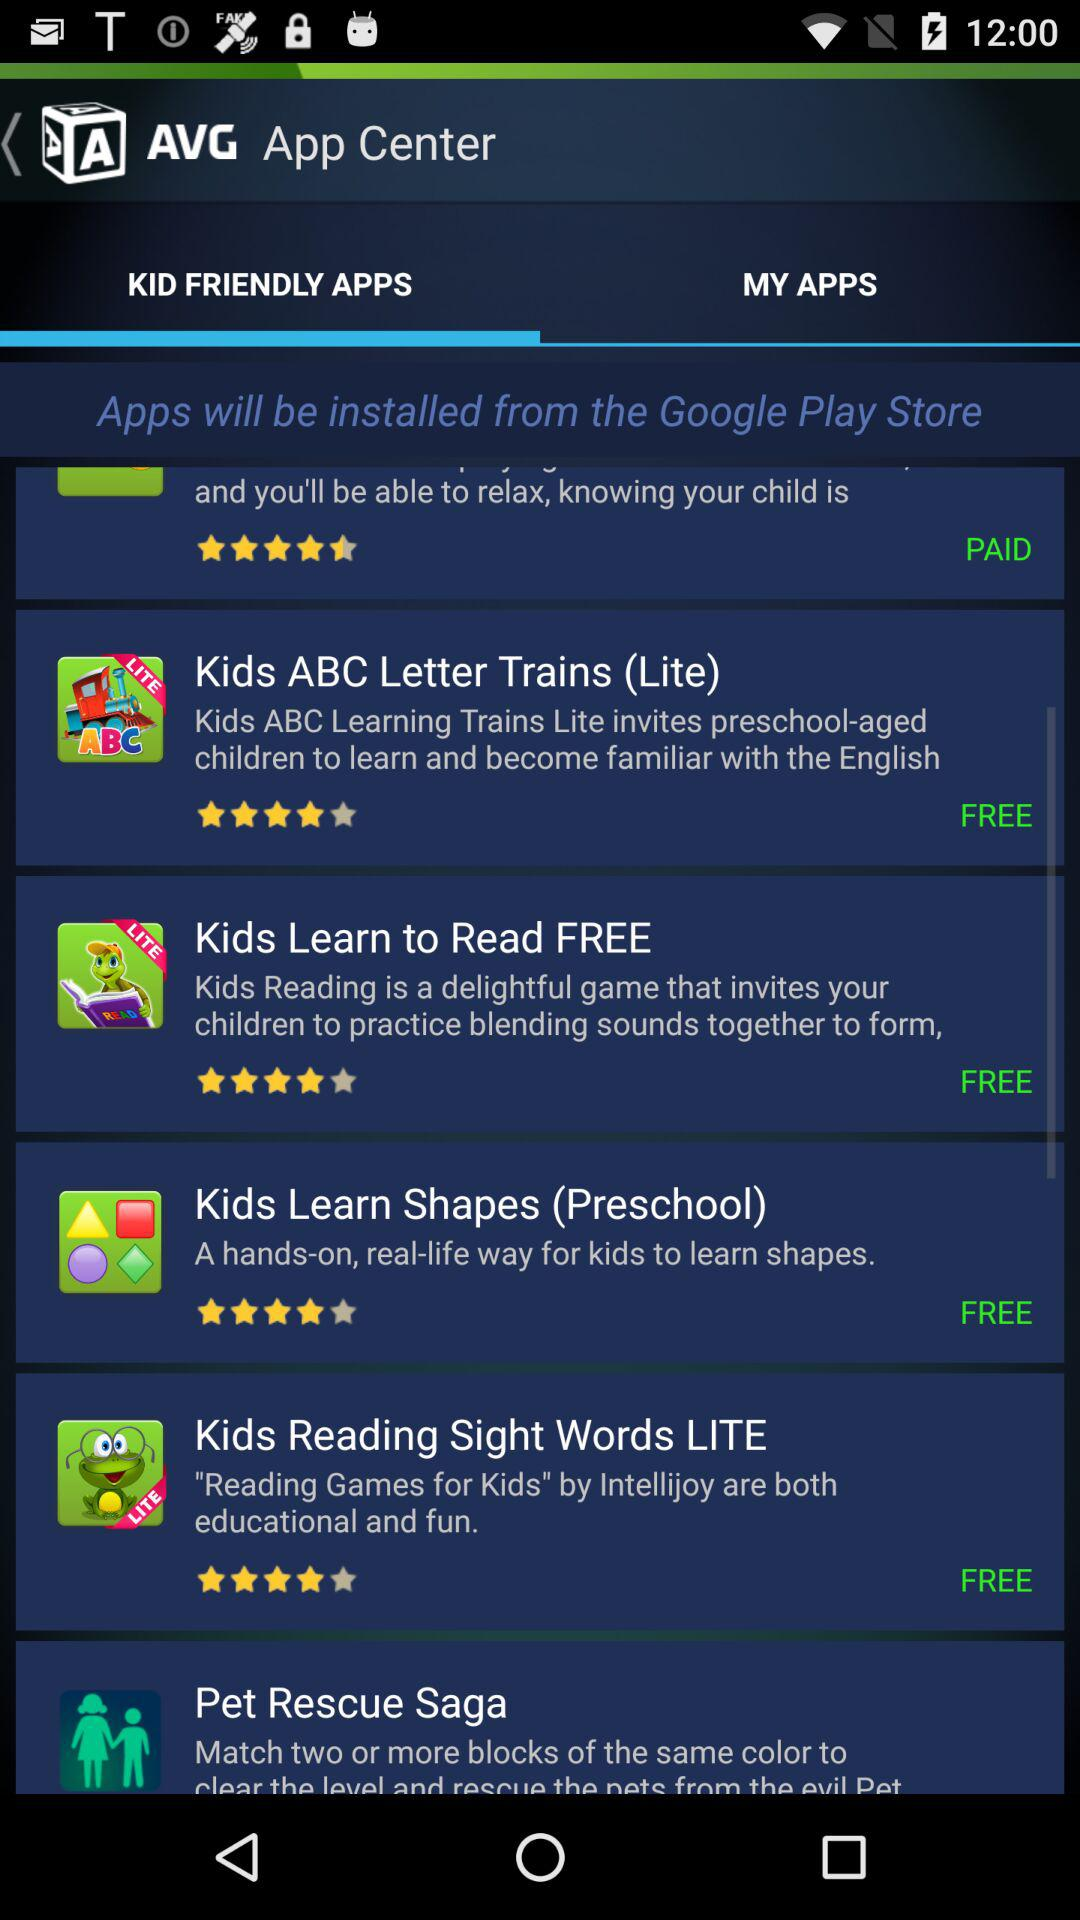How many apps are free?
Answer the question using a single word or phrase. 4 